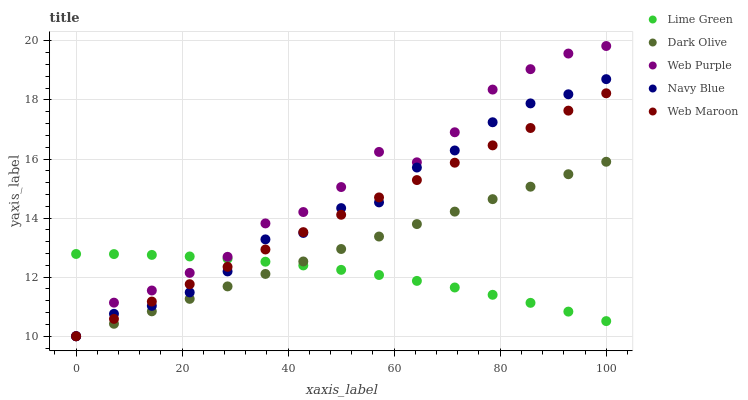Does Lime Green have the minimum area under the curve?
Answer yes or no. Yes. Does Web Purple have the maximum area under the curve?
Answer yes or no. Yes. Does Dark Olive have the minimum area under the curve?
Answer yes or no. No. Does Dark Olive have the maximum area under the curve?
Answer yes or no. No. Is Dark Olive the smoothest?
Answer yes or no. Yes. Is Web Purple the roughest?
Answer yes or no. Yes. Is Web Purple the smoothest?
Answer yes or no. No. Is Dark Olive the roughest?
Answer yes or no. No. Does Navy Blue have the lowest value?
Answer yes or no. Yes. Does Lime Green have the lowest value?
Answer yes or no. No. Does Web Purple have the highest value?
Answer yes or no. Yes. Does Dark Olive have the highest value?
Answer yes or no. No. Does Web Maroon intersect Dark Olive?
Answer yes or no. Yes. Is Web Maroon less than Dark Olive?
Answer yes or no. No. Is Web Maroon greater than Dark Olive?
Answer yes or no. No. 